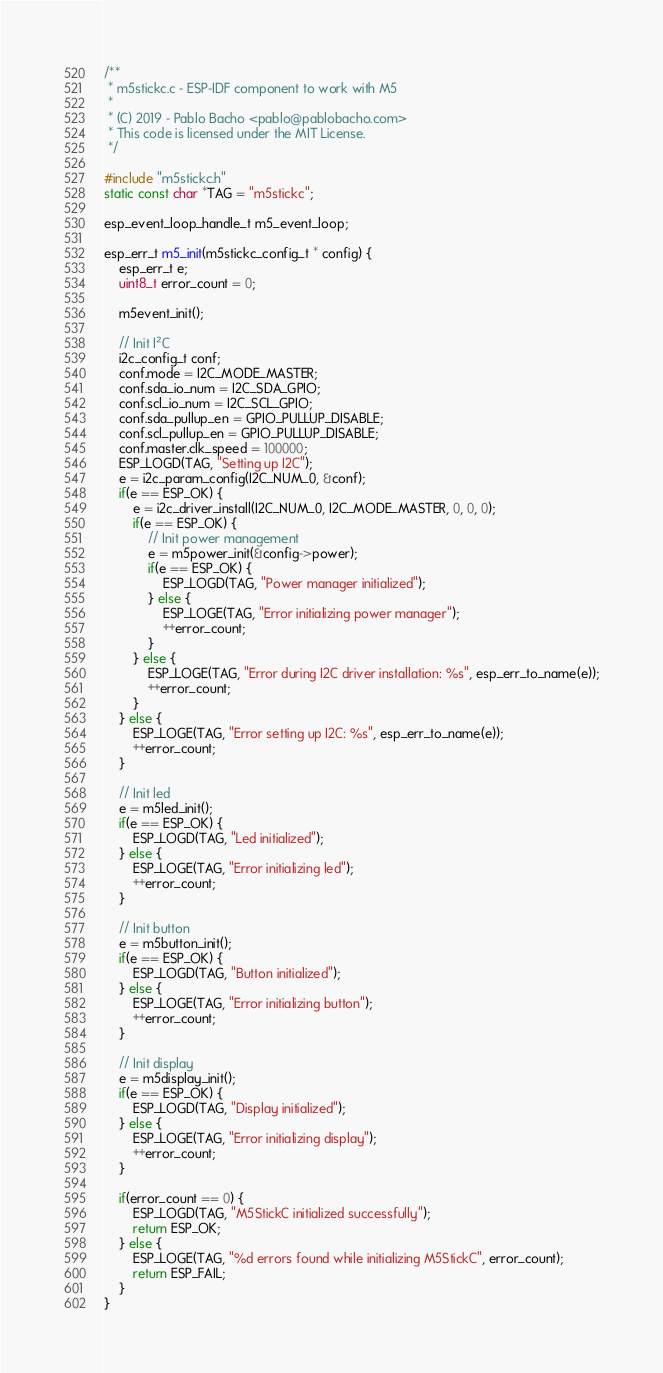Convert code to text. <code><loc_0><loc_0><loc_500><loc_500><_C_>/**
 * m5stickc.c - ESP-IDF component to work with M5
 *
 * (C) 2019 - Pablo Bacho <pablo@pablobacho.com>
 * This code is licensed under the MIT License.
 */

#include "m5stickc.h"
static const char *TAG = "m5stickc";

esp_event_loop_handle_t m5_event_loop;

esp_err_t m5_init(m5stickc_config_t * config) {
    esp_err_t e;
    uint8_t error_count = 0;

    m5event_init();

    // Init I²C
    i2c_config_t conf;
    conf.mode = I2C_MODE_MASTER;
    conf.sda_io_num = I2C_SDA_GPIO;
    conf.scl_io_num = I2C_SCL_GPIO;
    conf.sda_pullup_en = GPIO_PULLUP_DISABLE;
    conf.scl_pullup_en = GPIO_PULLUP_DISABLE;
    conf.master.clk_speed = 100000;
    ESP_LOGD(TAG, "Setting up I2C");
    e = i2c_param_config(I2C_NUM_0, &conf);
    if(e == ESP_OK) {
        e = i2c_driver_install(I2C_NUM_0, I2C_MODE_MASTER, 0, 0, 0);
        if(e == ESP_OK) {
            // Init power management
            e = m5power_init(&config->power);
            if(e == ESP_OK) {
                ESP_LOGD(TAG, "Power manager initialized");
            } else {
                ESP_LOGE(TAG, "Error initializing power manager");
                ++error_count;
            }
        } else {
            ESP_LOGE(TAG, "Error during I2C driver installation: %s", esp_err_to_name(e));
            ++error_count;
        }
    } else {
        ESP_LOGE(TAG, "Error setting up I2C: %s", esp_err_to_name(e));
        ++error_count;
    }

    // Init led
    e = m5led_init();
    if(e == ESP_OK) {
        ESP_LOGD(TAG, "Led initialized");
    } else {
        ESP_LOGE(TAG, "Error initializing led");
        ++error_count;
    }

    // Init button
    e = m5button_init();
    if(e == ESP_OK) {
        ESP_LOGD(TAG, "Button initialized");
    } else {
        ESP_LOGE(TAG, "Error initializing button");
        ++error_count;
    }

    // Init display
    e = m5display_init();
    if(e == ESP_OK) {
        ESP_LOGD(TAG, "Display initialized");
    } else {
        ESP_LOGE(TAG, "Error initializing display");
        ++error_count;
    }

    if(error_count == 0) {
        ESP_LOGD(TAG, "M5StickC initialized successfully");
        return ESP_OK;
    } else {
        ESP_LOGE(TAG, "%d errors found while initializing M5StickC", error_count);
        return ESP_FAIL;
    }
}</code> 